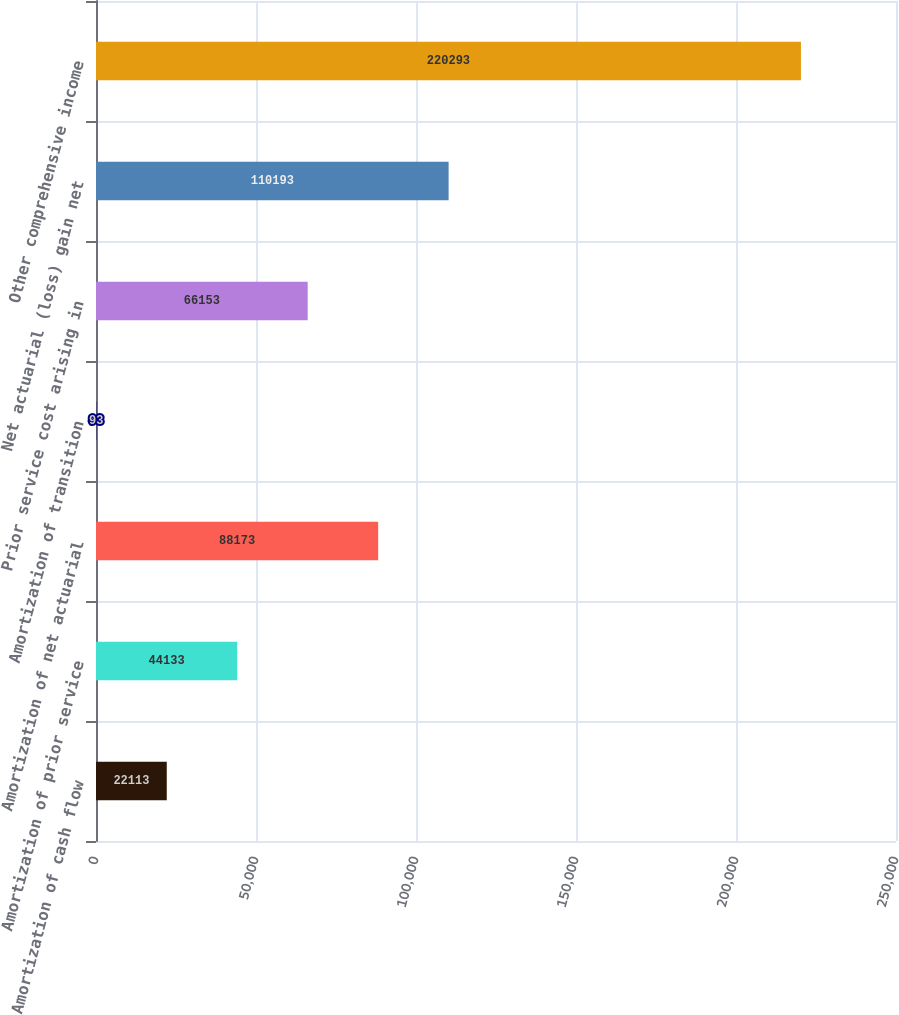Convert chart to OTSL. <chart><loc_0><loc_0><loc_500><loc_500><bar_chart><fcel>Amortization of cash flow<fcel>Amortization of prior service<fcel>Amortization of net actuarial<fcel>Amortization of transition<fcel>Prior service cost arising in<fcel>Net actuarial (loss) gain net<fcel>Other comprehensive income<nl><fcel>22113<fcel>44133<fcel>88173<fcel>93<fcel>66153<fcel>110193<fcel>220293<nl></chart> 